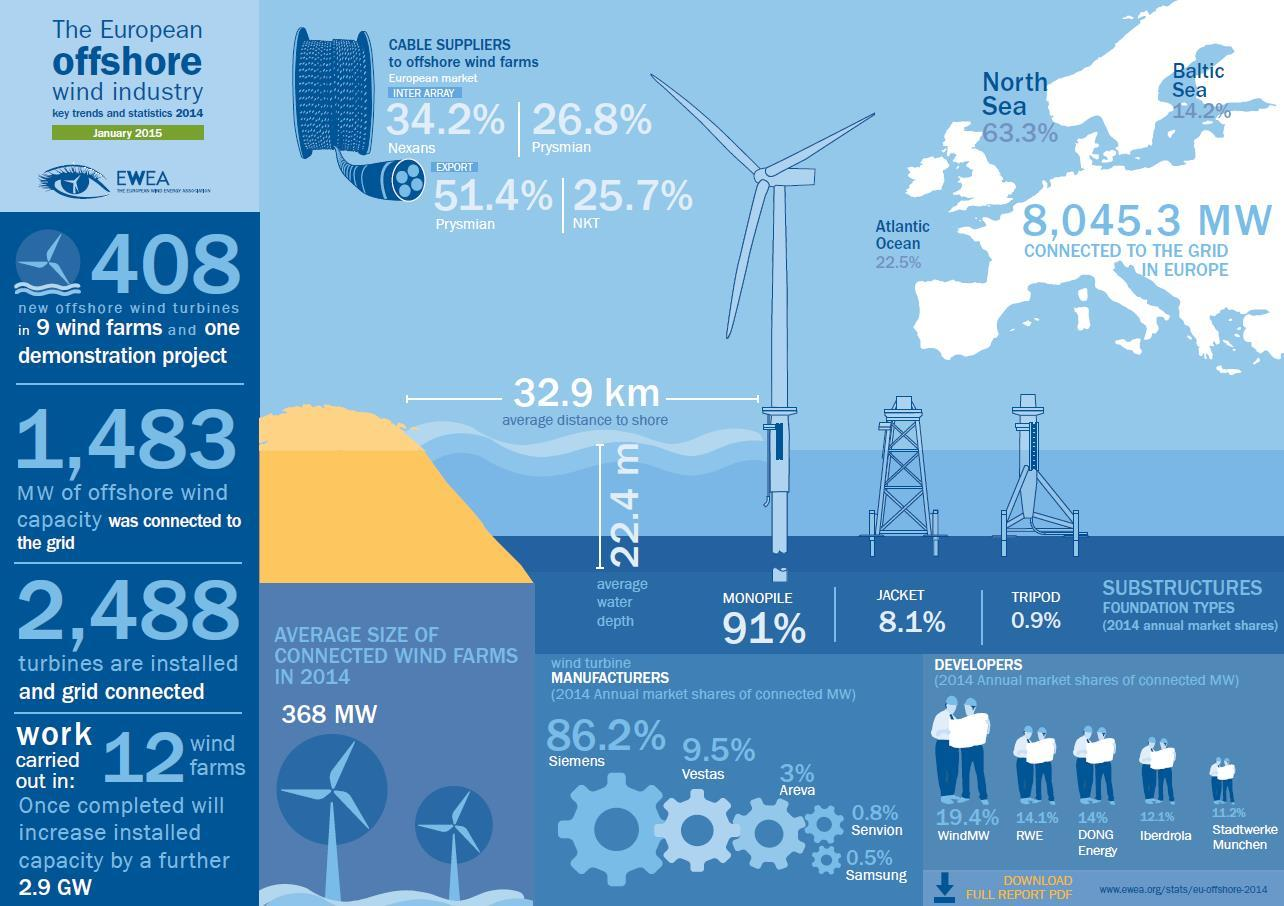Outline some significant characteristics in this image. According to the data, Monopile is the substructure foundation type that has been used in 91% of the wind turbines. According to recent reports, Samsung, as a wind turbine manufacturer, contributes only 0.5% to the overall production of wind turbines globally. Tripod has a substructure foundation type with a percentage of 0.9%. 